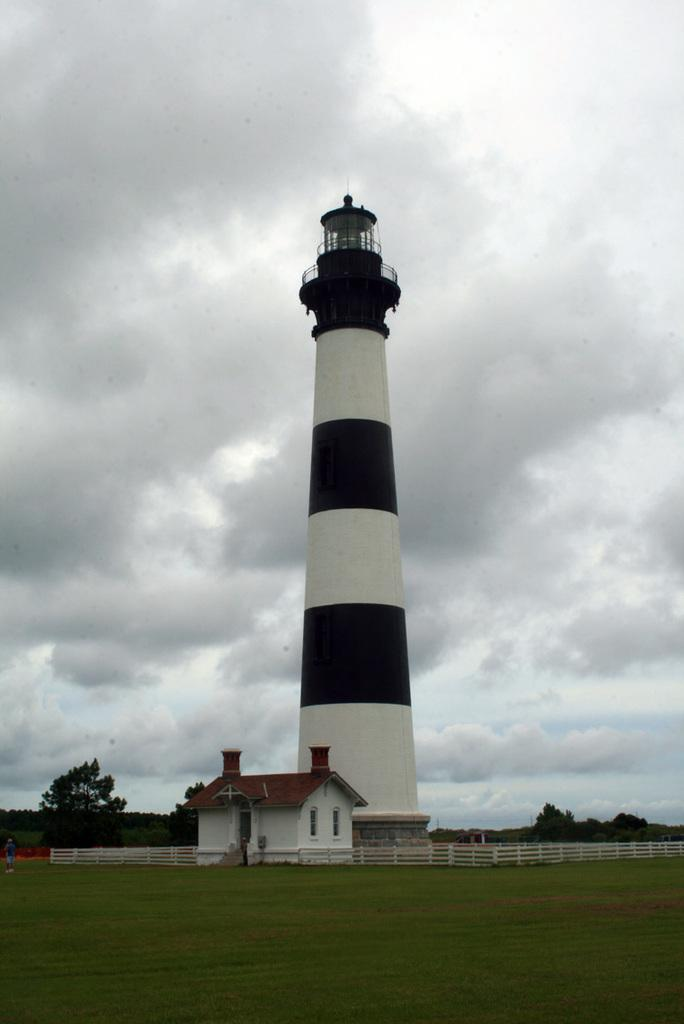What is the main structure visible in the image? There is a lighthouse in the image. What type of terrain is present in the image? There is grassy land in the image. Is there any barrier or enclosure visible in the image? Yes, there is a fence in the image. What can be seen in the sky in the image? There are clouds visible in the sky. How many frogs are sitting on the lighthouse in the image? There are no frogs present in the image. What type of spy equipment can be seen in the image? There is no spy equipment present in the image. 